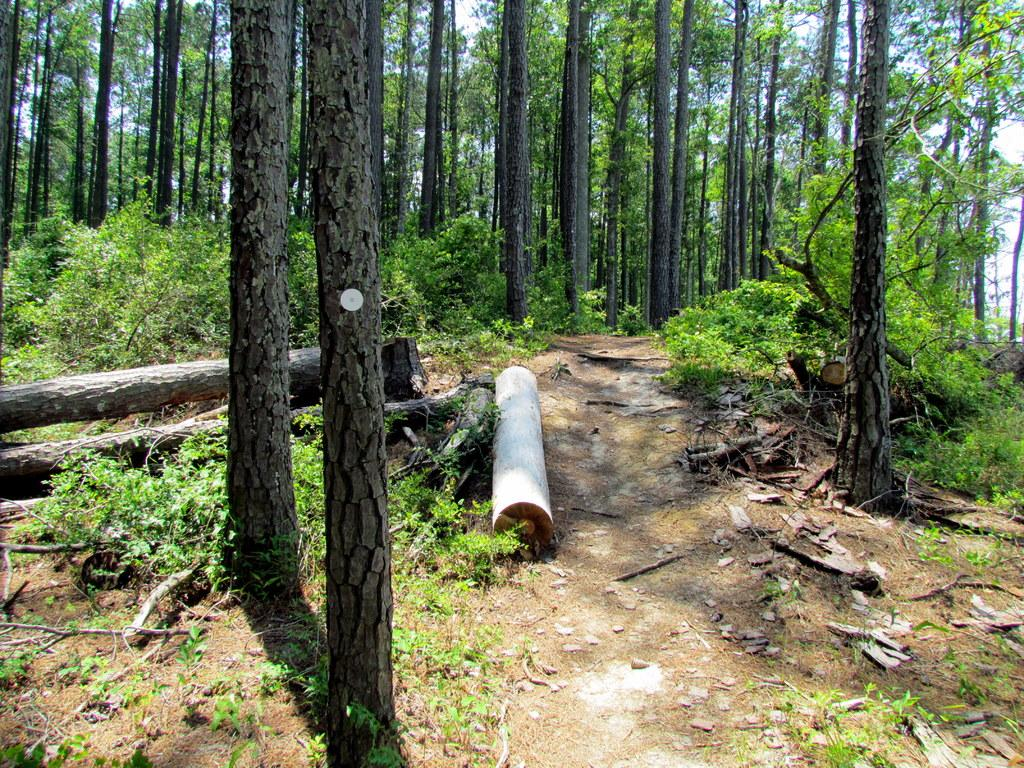What type of vegetation can be seen in the image? There are trees, branches, and plants in the image. Can you describe the branches in the image? The branches are part of the trees and are visible in the image. What is visible through the trees in the image? The sky is visible through the trees in the image. What type of bean is growing on the stage in the image? There is no stage or bean present in the image. 